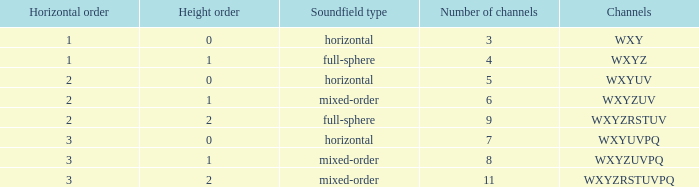What is the count of channels in the wxyzuv sequence? 6.0. 